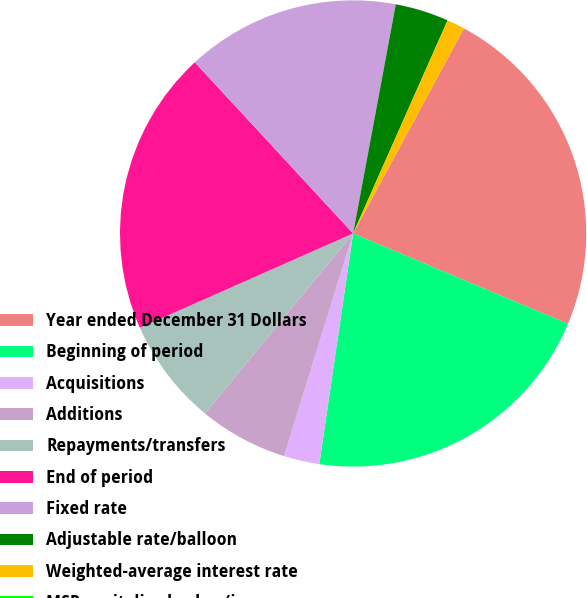Convert chart to OTSL. <chart><loc_0><loc_0><loc_500><loc_500><pie_chart><fcel>Year ended December 31 Dollars<fcel>Beginning of period<fcel>Acquisitions<fcel>Additions<fcel>Repayments/transfers<fcel>End of period<fcel>Fixed rate<fcel>Adjustable rate/balloon<fcel>Weighted-average interest rate<fcel>MSR capitalized value (in<nl><fcel>23.45%<fcel>20.98%<fcel>2.47%<fcel>6.17%<fcel>7.41%<fcel>19.75%<fcel>14.81%<fcel>3.71%<fcel>1.24%<fcel>0.0%<nl></chart> 